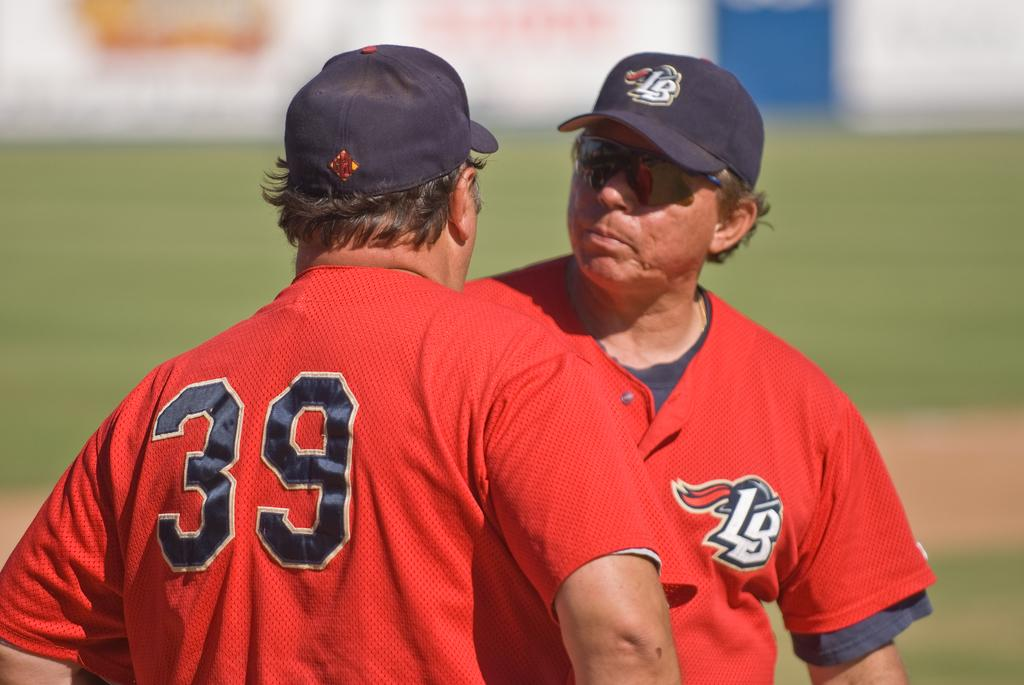How many people are in the image? There are two persons in the image. What are the persons wearing on their heads? The persons are wearing caps. Can you describe the background of the image? The background of the image is blurred. What type of cabbage can be seen growing in the background of the image? There is no cabbage present in the image, and the background is blurred, so it is not possible to determine if any cabbage is growing. 